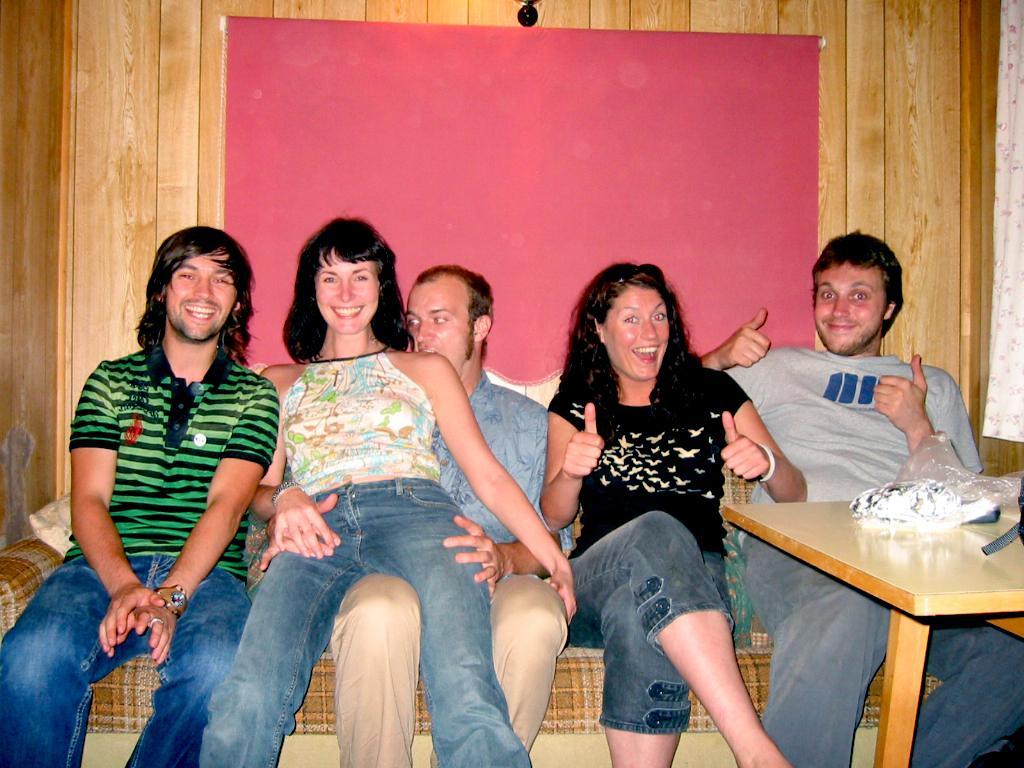In one or two sentences, can you explain what this image depicts? This is the image where five people are sitting on the sofa among them there are men and two are woman. On the right side of the image there is a table. In the background of the image there is a wooden wall. 